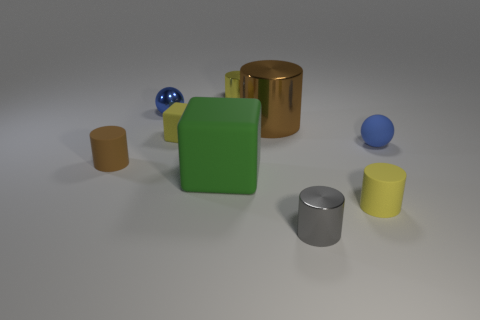What number of small metal things have the same color as the small rubber cube?
Offer a very short reply. 1. Is the number of brown metal objects left of the big brown metal thing less than the number of tiny yellow metallic cylinders to the left of the small matte cube?
Your answer should be very brief. No. What is the material of the tiny brown object?
Provide a short and direct response. Rubber. There is a small matte sphere; is its color the same as the tiny object on the left side of the shiny ball?
Provide a short and direct response. No. There is a tiny brown matte object; what number of matte cylinders are right of it?
Ensure brevity in your answer.  1. Are there fewer small yellow things on the right side of the yellow shiny object than small gray objects?
Ensure brevity in your answer.  No. The tiny cube is what color?
Offer a very short reply. Yellow. Do the rubber cylinder on the left side of the large brown metal thing and the large rubber thing have the same color?
Give a very brief answer. No. What is the color of the other small shiny thing that is the same shape as the small yellow metal thing?
Provide a succinct answer. Gray. How many small objects are either brown shiny cylinders or gray rubber spheres?
Your answer should be very brief. 0. 